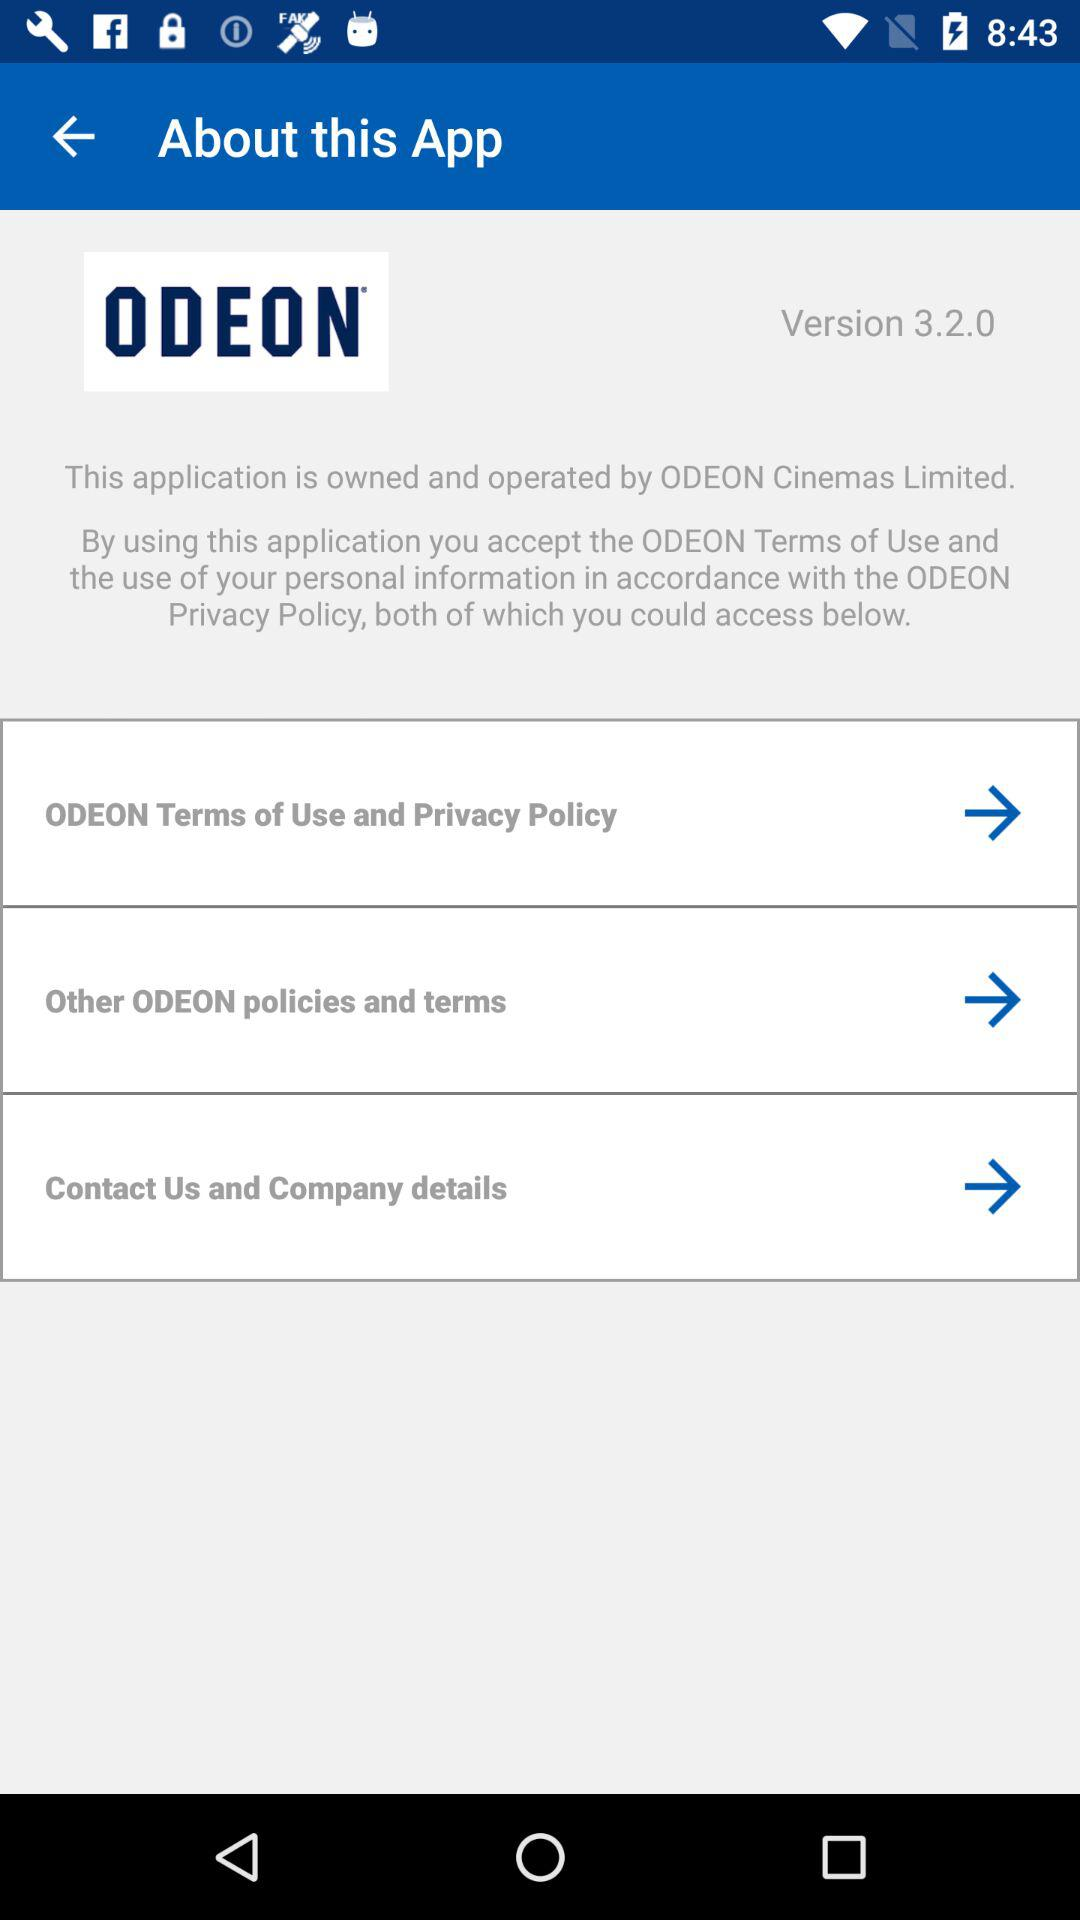By whom is the application owned and operated? The application is owned and operated by ODEON Cinemas Limited. 